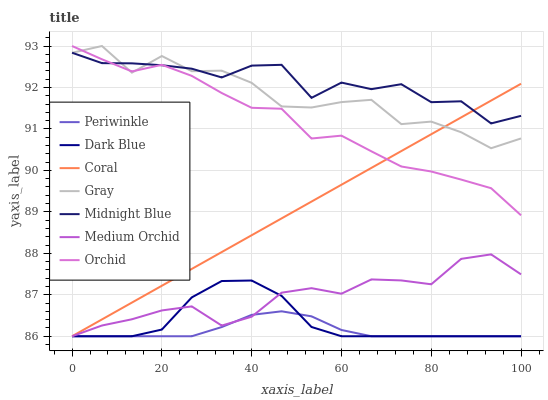Does Periwinkle have the minimum area under the curve?
Answer yes or no. Yes. Does Midnight Blue have the maximum area under the curve?
Answer yes or no. Yes. Does Coral have the minimum area under the curve?
Answer yes or no. No. Does Coral have the maximum area under the curve?
Answer yes or no. No. Is Coral the smoothest?
Answer yes or no. Yes. Is Gray the roughest?
Answer yes or no. Yes. Is Midnight Blue the smoothest?
Answer yes or no. No. Is Midnight Blue the roughest?
Answer yes or no. No. Does Coral have the lowest value?
Answer yes or no. Yes. Does Midnight Blue have the lowest value?
Answer yes or no. No. Does Orchid have the highest value?
Answer yes or no. Yes. Does Midnight Blue have the highest value?
Answer yes or no. No. Is Periwinkle less than Midnight Blue?
Answer yes or no. Yes. Is Midnight Blue greater than Periwinkle?
Answer yes or no. Yes. Does Midnight Blue intersect Coral?
Answer yes or no. Yes. Is Midnight Blue less than Coral?
Answer yes or no. No. Is Midnight Blue greater than Coral?
Answer yes or no. No. Does Periwinkle intersect Midnight Blue?
Answer yes or no. No. 